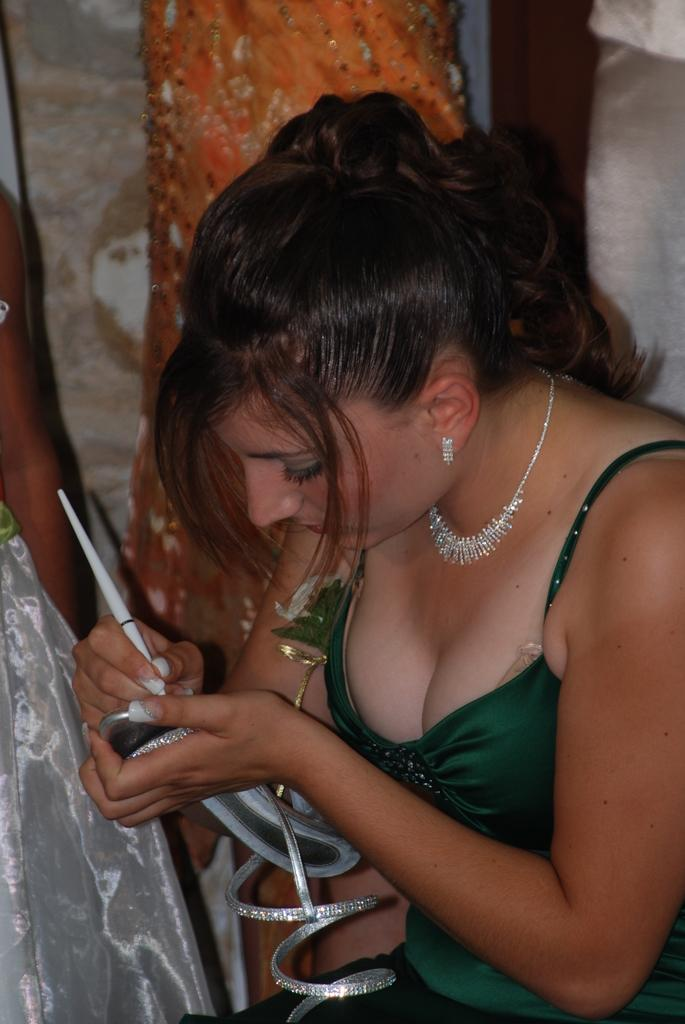What is the main subject of the image? The main subject of the image is a woman. What is the woman holding in her hands? The woman is holding a chappal (sandal) in her hands. What is the woman doing with the chappal? The woman is writing on the chappal. What can be seen in the background of the image? There is a wall in the background of the image. What type of horn can be seen on the woman's head in the image? There is no horn visible on the woman's head in the image. What type of army is present in the image? There is no army present in the image; it features a woman writing on a chappal. 